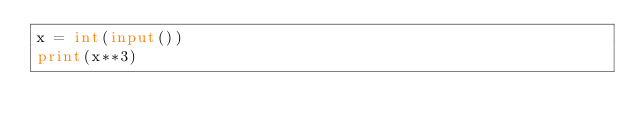<code> <loc_0><loc_0><loc_500><loc_500><_Python_>x = int(input())
print(x**3)
</code> 